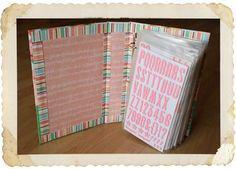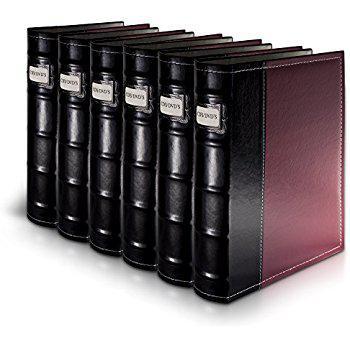The first image is the image on the left, the second image is the image on the right. Evaluate the accuracy of this statement regarding the images: "1 of the images has 6 shelf objects lined up in a row next to each other.". Is it true? Answer yes or no. Yes. The first image is the image on the left, the second image is the image on the right. For the images shown, is this caption "Exactly six binders of equal size are shown in one image." true? Answer yes or no. Yes. 